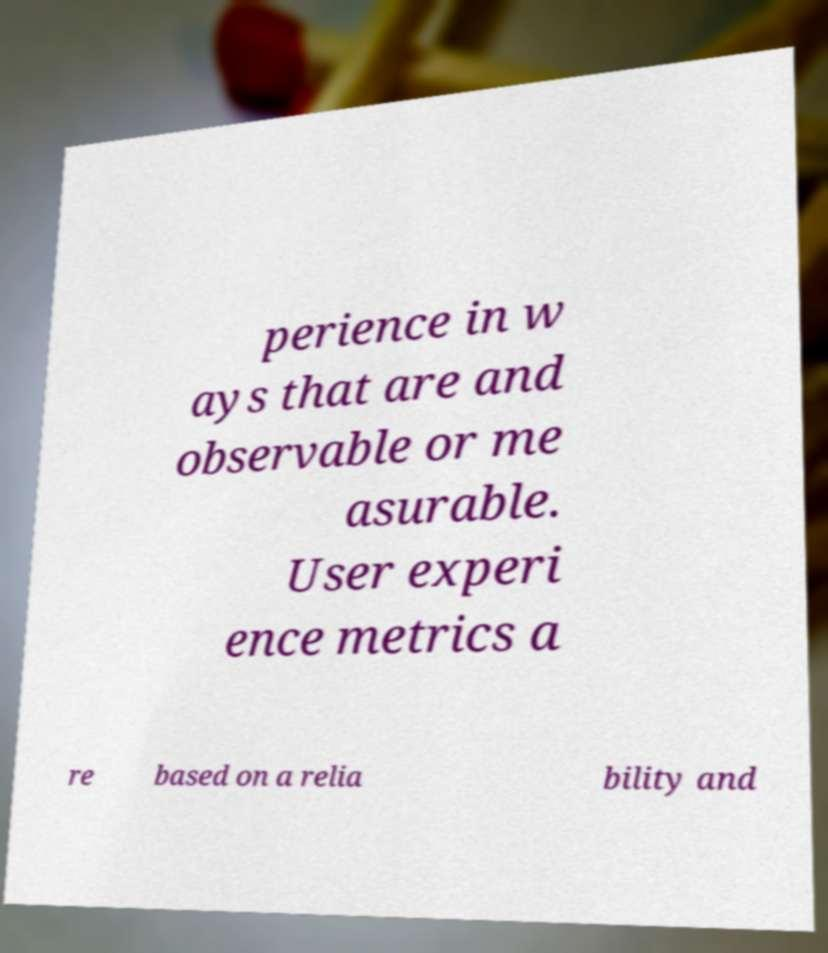Can you read and provide the text displayed in the image?This photo seems to have some interesting text. Can you extract and type it out for me? perience in w ays that are and observable or me asurable. User experi ence metrics a re based on a relia bility and 